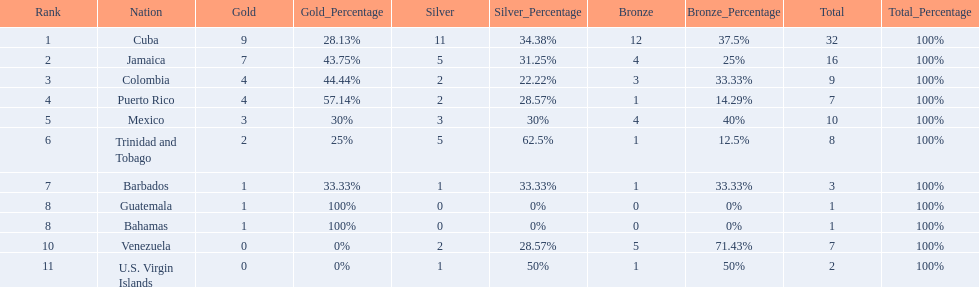Which 3 countries were awarded the most medals? Cuba, Jamaica, Colombia. Of these 3 countries which ones are islands? Cuba, Jamaica. Which one won the most silver medals? Cuba. Which nations played in the games? Cuba, Jamaica, Colombia, Puerto Rico, Mexico, Trinidad and Tobago, Barbados, Guatemala, Bahamas, Venezuela, U.S. Virgin Islands. Would you be able to parse every entry in this table? {'header': ['Rank', 'Nation', 'Gold', 'Gold_Percentage', 'Silver', 'Silver_Percentage', 'Bronze', 'Bronze_Percentage', 'Total', 'Total_Percentage'], 'rows': [['1', 'Cuba', '9', '28.13%', '11', '34.38%', '12', '37.5%', '32', '100%'], ['2', 'Jamaica', '7', '43.75%', '5', '31.25%', '4', '25%', '16', '100%'], ['3', 'Colombia', '4', '44.44%', '2', '22.22%', '3', '33.33%', '9', '100%'], ['4', 'Puerto Rico', '4', '57.14%', '2', '28.57%', '1', '14.29%', '7', '100%'], ['5', 'Mexico', '3', '30%', '3', '30%', '4', '40%', '10', '100%'], ['6', 'Trinidad and Tobago', '2', '25%', '5', '62.5%', '1', '12.5%', '8', '100%'], ['7', 'Barbados', '1', '33.33%', '1', '33.33%', '1', '33.33%', '3', '100%'], ['8', 'Guatemala', '1', '100%', '0', '0%', '0', '0%', '1', '100%'], ['8', 'Bahamas', '1', '100%', '0', '0%', '0', '0%', '1', '100%'], ['10', 'Venezuela', '0', '0%', '2', '28.57%', '5', '71.43%', '7', '100%'], ['11', 'U.S. Virgin Islands', '0', '0%', '1', '50%', '1', '50%', '2', '100%']]} How many silver medals did they win? 11, 5, 2, 2, 3, 5, 1, 0, 0, 2, 1. Which team won the most silver? Cuba. 